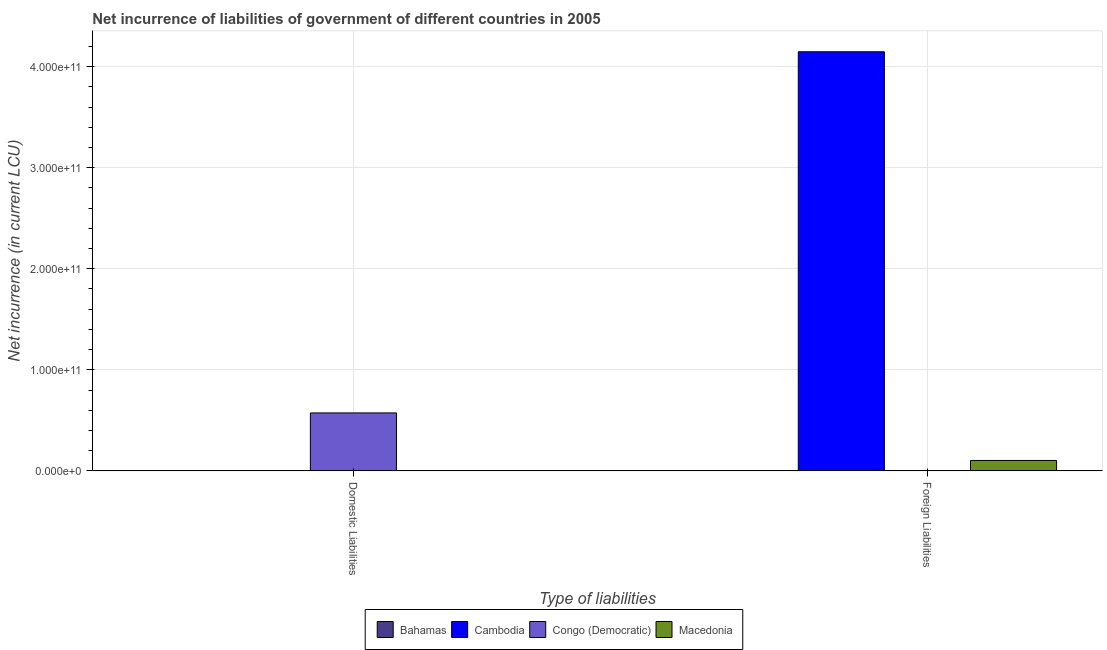How many different coloured bars are there?
Offer a terse response. 4. Are the number of bars per tick equal to the number of legend labels?
Ensure brevity in your answer.  No. What is the label of the 2nd group of bars from the left?
Provide a succinct answer. Foreign Liabilities. Across all countries, what is the maximum net incurrence of domestic liabilities?
Ensure brevity in your answer.  5.74e+1. Across all countries, what is the minimum net incurrence of domestic liabilities?
Make the answer very short. 0. In which country was the net incurrence of domestic liabilities maximum?
Provide a short and direct response. Congo (Democratic). What is the total net incurrence of domestic liabilities in the graph?
Your answer should be compact. 5.75e+1. What is the difference between the net incurrence of foreign liabilities in Macedonia and that in Cambodia?
Ensure brevity in your answer.  -4.04e+11. What is the difference between the net incurrence of domestic liabilities in Bahamas and the net incurrence of foreign liabilities in Macedonia?
Provide a short and direct response. -1.01e+1. What is the average net incurrence of domestic liabilities per country?
Your answer should be compact. 1.44e+1. What is the difference between the net incurrence of foreign liabilities and net incurrence of domestic liabilities in Bahamas?
Your response must be concise. -1.75e+08. In how many countries, is the net incurrence of domestic liabilities greater than 220000000000 LCU?
Give a very brief answer. 0. Are all the bars in the graph horizontal?
Make the answer very short. No. How many countries are there in the graph?
Your answer should be very brief. 4. What is the difference between two consecutive major ticks on the Y-axis?
Offer a terse response. 1.00e+11. Are the values on the major ticks of Y-axis written in scientific E-notation?
Your answer should be compact. Yes. Where does the legend appear in the graph?
Your answer should be very brief. Bottom center. What is the title of the graph?
Provide a short and direct response. Net incurrence of liabilities of government of different countries in 2005. What is the label or title of the X-axis?
Provide a short and direct response. Type of liabilities. What is the label or title of the Y-axis?
Provide a succinct answer. Net incurrence (in current LCU). What is the Net incurrence (in current LCU) of Bahamas in Domestic Liabilities?
Ensure brevity in your answer.  1.76e+08. What is the Net incurrence (in current LCU) in Cambodia in Domestic Liabilities?
Make the answer very short. 0. What is the Net incurrence (in current LCU) of Congo (Democratic) in Domestic Liabilities?
Your response must be concise. 5.74e+1. What is the Net incurrence (in current LCU) of Bahamas in Foreign Liabilities?
Make the answer very short. 1.70e+06. What is the Net incurrence (in current LCU) in Cambodia in Foreign Liabilities?
Make the answer very short. 4.15e+11. What is the Net incurrence (in current LCU) of Macedonia in Foreign Liabilities?
Provide a short and direct response. 1.03e+1. Across all Type of liabilities, what is the maximum Net incurrence (in current LCU) in Bahamas?
Provide a short and direct response. 1.76e+08. Across all Type of liabilities, what is the maximum Net incurrence (in current LCU) of Cambodia?
Provide a succinct answer. 4.15e+11. Across all Type of liabilities, what is the maximum Net incurrence (in current LCU) in Congo (Democratic)?
Your response must be concise. 5.74e+1. Across all Type of liabilities, what is the maximum Net incurrence (in current LCU) in Macedonia?
Provide a short and direct response. 1.03e+1. Across all Type of liabilities, what is the minimum Net incurrence (in current LCU) in Bahamas?
Your answer should be very brief. 1.70e+06. Across all Type of liabilities, what is the minimum Net incurrence (in current LCU) in Congo (Democratic)?
Provide a short and direct response. 0. What is the total Net incurrence (in current LCU) of Bahamas in the graph?
Ensure brevity in your answer.  1.78e+08. What is the total Net incurrence (in current LCU) of Cambodia in the graph?
Ensure brevity in your answer.  4.15e+11. What is the total Net incurrence (in current LCU) of Congo (Democratic) in the graph?
Keep it short and to the point. 5.74e+1. What is the total Net incurrence (in current LCU) of Macedonia in the graph?
Provide a succinct answer. 1.03e+1. What is the difference between the Net incurrence (in current LCU) of Bahamas in Domestic Liabilities and that in Foreign Liabilities?
Make the answer very short. 1.75e+08. What is the difference between the Net incurrence (in current LCU) in Bahamas in Domestic Liabilities and the Net incurrence (in current LCU) in Cambodia in Foreign Liabilities?
Provide a succinct answer. -4.14e+11. What is the difference between the Net incurrence (in current LCU) of Bahamas in Domestic Liabilities and the Net incurrence (in current LCU) of Macedonia in Foreign Liabilities?
Offer a very short reply. -1.01e+1. What is the difference between the Net incurrence (in current LCU) of Congo (Democratic) in Domestic Liabilities and the Net incurrence (in current LCU) of Macedonia in Foreign Liabilities?
Offer a very short reply. 4.70e+1. What is the average Net incurrence (in current LCU) of Bahamas per Type of liabilities?
Your answer should be compact. 8.90e+07. What is the average Net incurrence (in current LCU) in Cambodia per Type of liabilities?
Your answer should be very brief. 2.07e+11. What is the average Net incurrence (in current LCU) in Congo (Democratic) per Type of liabilities?
Your answer should be very brief. 2.87e+1. What is the average Net incurrence (in current LCU) in Macedonia per Type of liabilities?
Keep it short and to the point. 5.16e+09. What is the difference between the Net incurrence (in current LCU) of Bahamas and Net incurrence (in current LCU) of Congo (Democratic) in Domestic Liabilities?
Your response must be concise. -5.72e+1. What is the difference between the Net incurrence (in current LCU) in Bahamas and Net incurrence (in current LCU) in Cambodia in Foreign Liabilities?
Your response must be concise. -4.15e+11. What is the difference between the Net incurrence (in current LCU) in Bahamas and Net incurrence (in current LCU) in Macedonia in Foreign Liabilities?
Your answer should be very brief. -1.03e+1. What is the difference between the Net incurrence (in current LCU) of Cambodia and Net incurrence (in current LCU) of Macedonia in Foreign Liabilities?
Provide a succinct answer. 4.04e+11. What is the ratio of the Net incurrence (in current LCU) in Bahamas in Domestic Liabilities to that in Foreign Liabilities?
Make the answer very short. 103.72. What is the difference between the highest and the second highest Net incurrence (in current LCU) in Bahamas?
Ensure brevity in your answer.  1.75e+08. What is the difference between the highest and the lowest Net incurrence (in current LCU) in Bahamas?
Provide a short and direct response. 1.75e+08. What is the difference between the highest and the lowest Net incurrence (in current LCU) of Cambodia?
Keep it short and to the point. 4.15e+11. What is the difference between the highest and the lowest Net incurrence (in current LCU) of Congo (Democratic)?
Your response must be concise. 5.74e+1. What is the difference between the highest and the lowest Net incurrence (in current LCU) in Macedonia?
Give a very brief answer. 1.03e+1. 